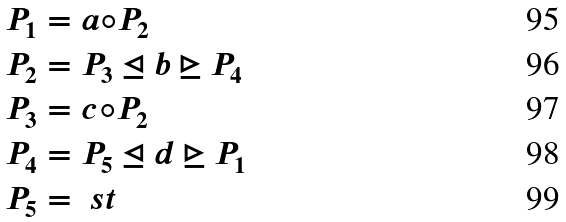<formula> <loc_0><loc_0><loc_500><loc_500>P _ { 1 } & = a \circ P _ { 2 } \\ P _ { 2 } & = P _ { 3 } \unlhd b \unrhd P _ { 4 } \\ P _ { 3 } & = c \circ P _ { 2 } \\ P _ { 4 } & = P _ { 5 } \unlhd d \unrhd P _ { 1 } \\ P _ { 5 } & = \ s t</formula> 